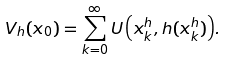Convert formula to latex. <formula><loc_0><loc_0><loc_500><loc_500>V _ { h } ( x _ { 0 } ) = \sum _ { { k } = 0 } ^ { \infty } { U \left ( x _ { k } ^ { h } , h ( x _ { k } ^ { h } ) \right ) } .</formula> 